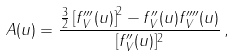Convert formula to latex. <formula><loc_0><loc_0><loc_500><loc_500>A ( u ) = \frac { \frac { 3 } { 2 } \left [ f _ { V } ^ { \prime \prime \prime } ( u ) \right ] ^ { 2 } - f _ { V } ^ { \prime \prime } ( u ) f _ { V } ^ { \prime \prime \prime \prime } ( u ) } { [ f _ { V } ^ { \prime \prime } ( u ) ] ^ { 2 } } \, ,</formula> 